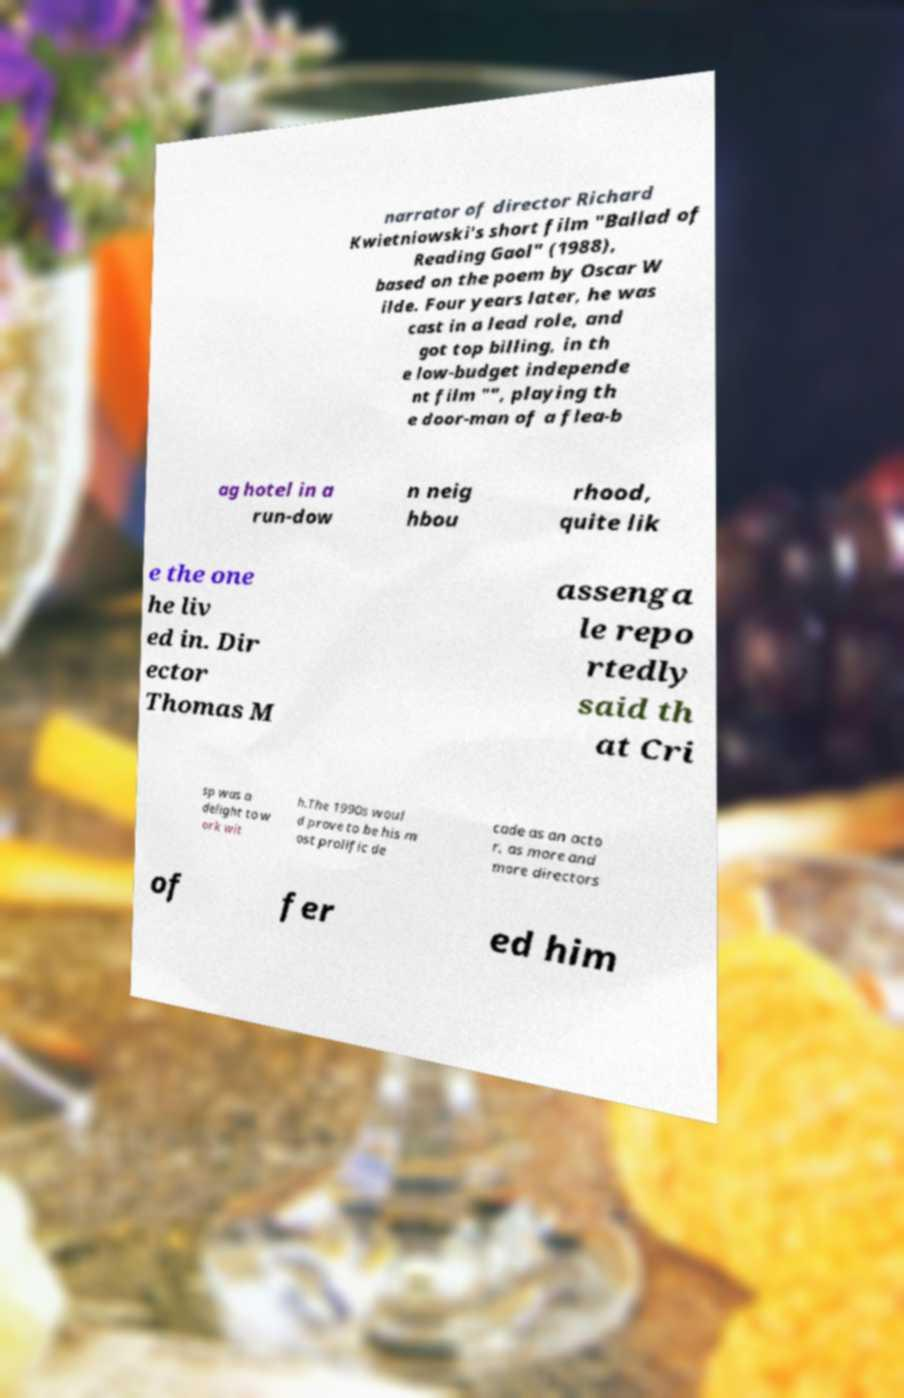Please identify and transcribe the text found in this image. narrator of director Richard Kwietniowski's short film "Ballad of Reading Gaol" (1988), based on the poem by Oscar W ilde. Four years later, he was cast in a lead role, and got top billing, in th e low-budget independe nt film "", playing th e door-man of a flea-b ag hotel in a run-dow n neig hbou rhood, quite lik e the one he liv ed in. Dir ector Thomas M assenga le repo rtedly said th at Cri sp was a delight to w ork wit h.The 1990s woul d prove to be his m ost prolific de cade as an acto r, as more and more directors of fer ed him 